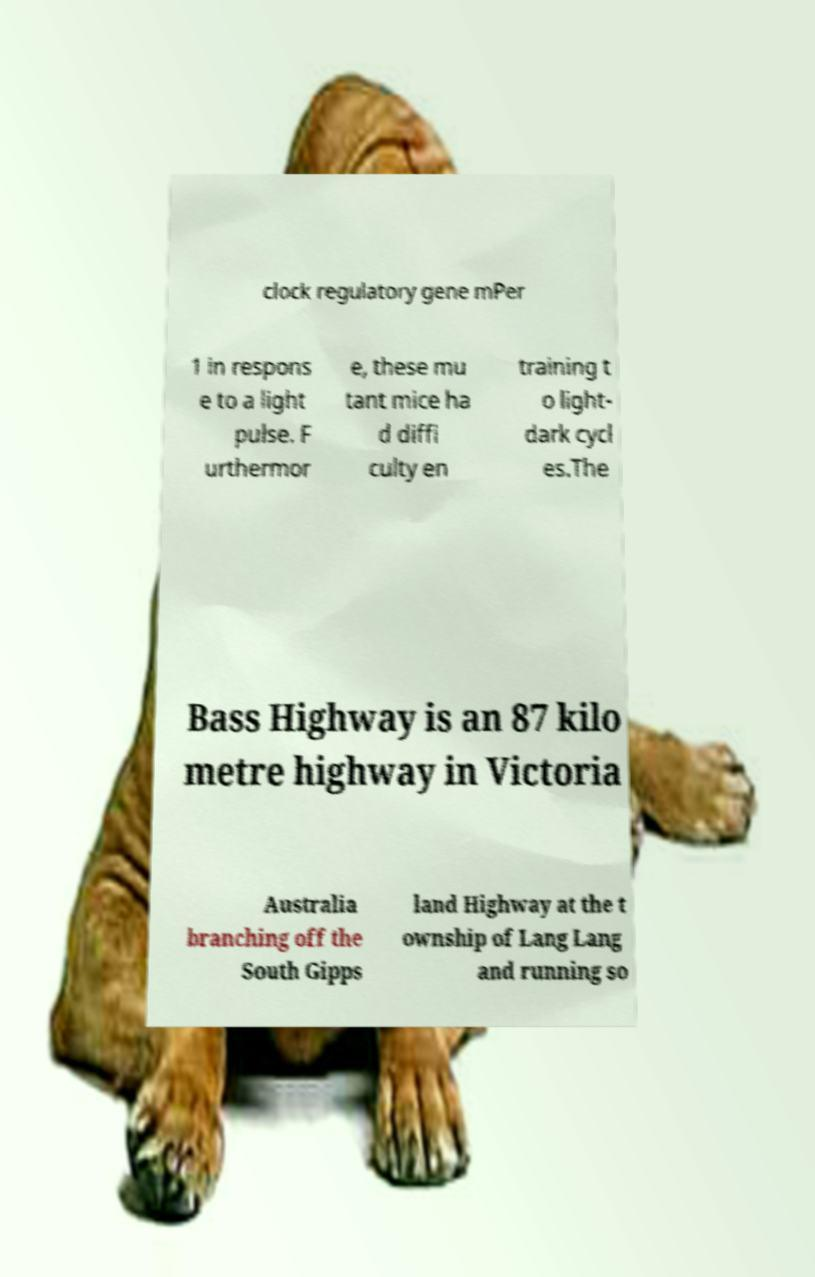There's text embedded in this image that I need extracted. Can you transcribe it verbatim? clock regulatory gene mPer 1 in respons e to a light pulse. F urthermor e, these mu tant mice ha d diffi culty en training t o light- dark cycl es.The Bass Highway is an 87 kilo metre highway in Victoria Australia branching off the South Gipps land Highway at the t ownship of Lang Lang and running so 